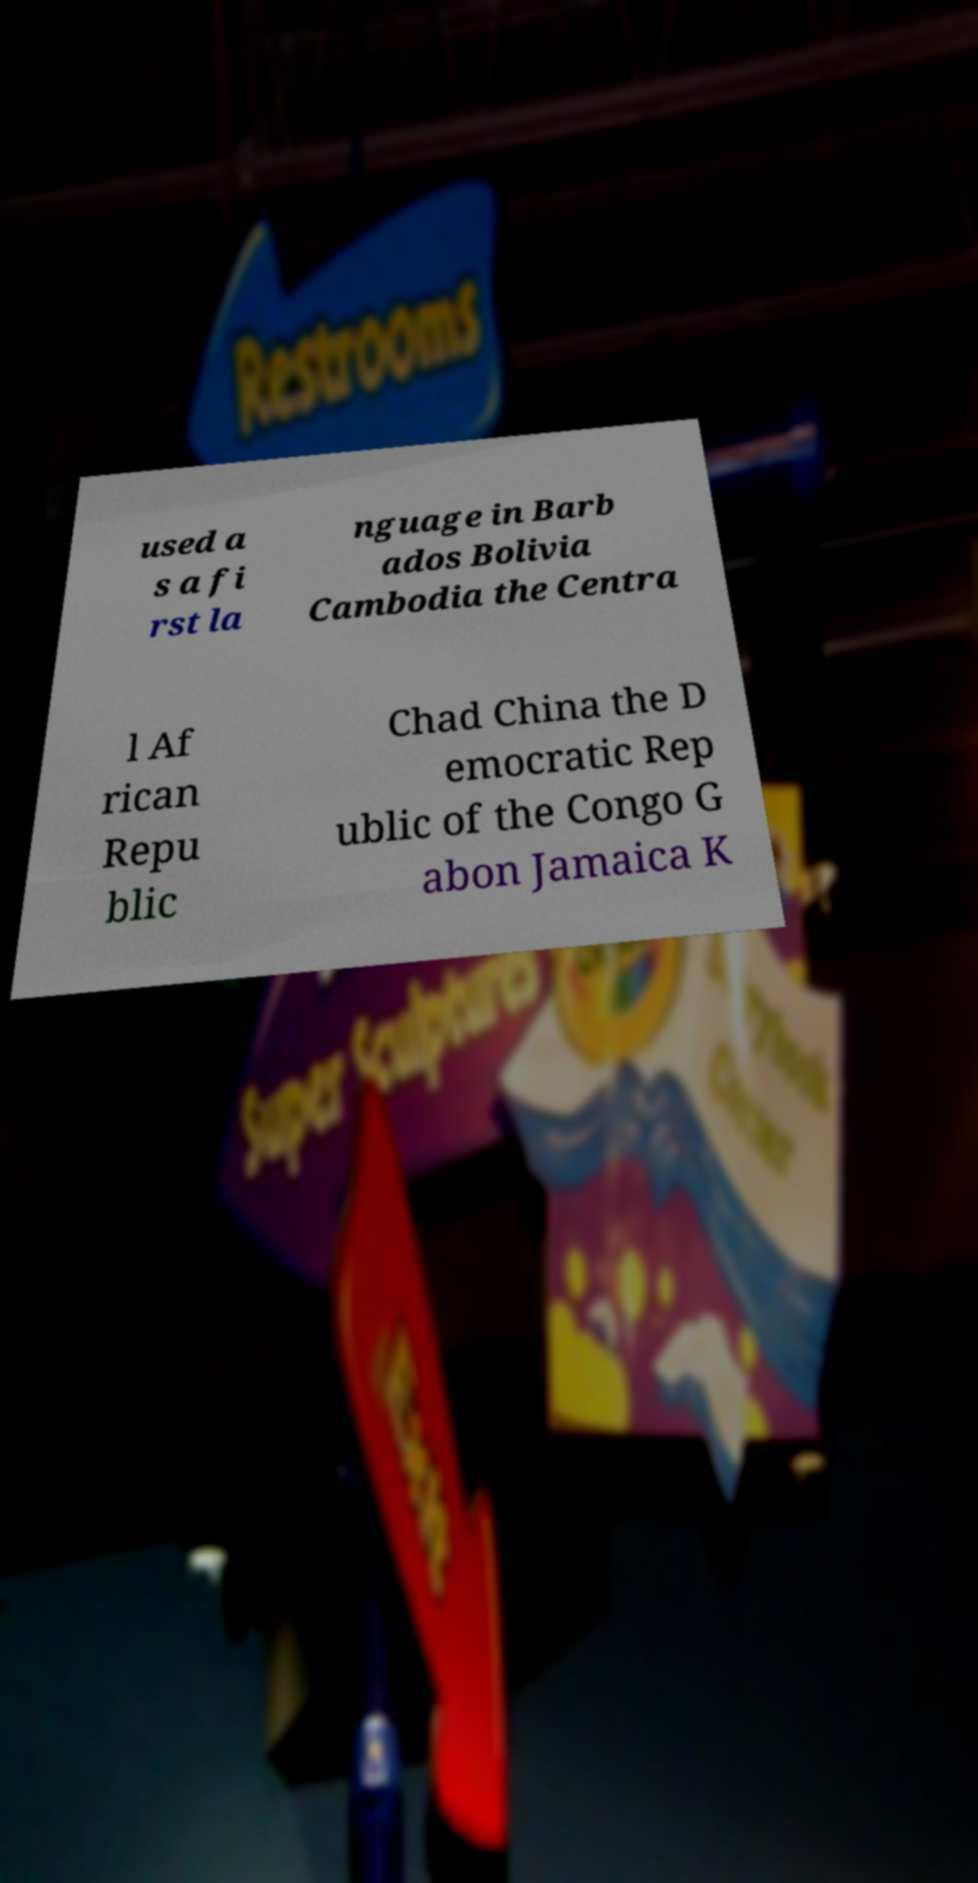What messages or text are displayed in this image? I need them in a readable, typed format. used a s a fi rst la nguage in Barb ados Bolivia Cambodia the Centra l Af rican Repu blic Chad China the D emocratic Rep ublic of the Congo G abon Jamaica K 